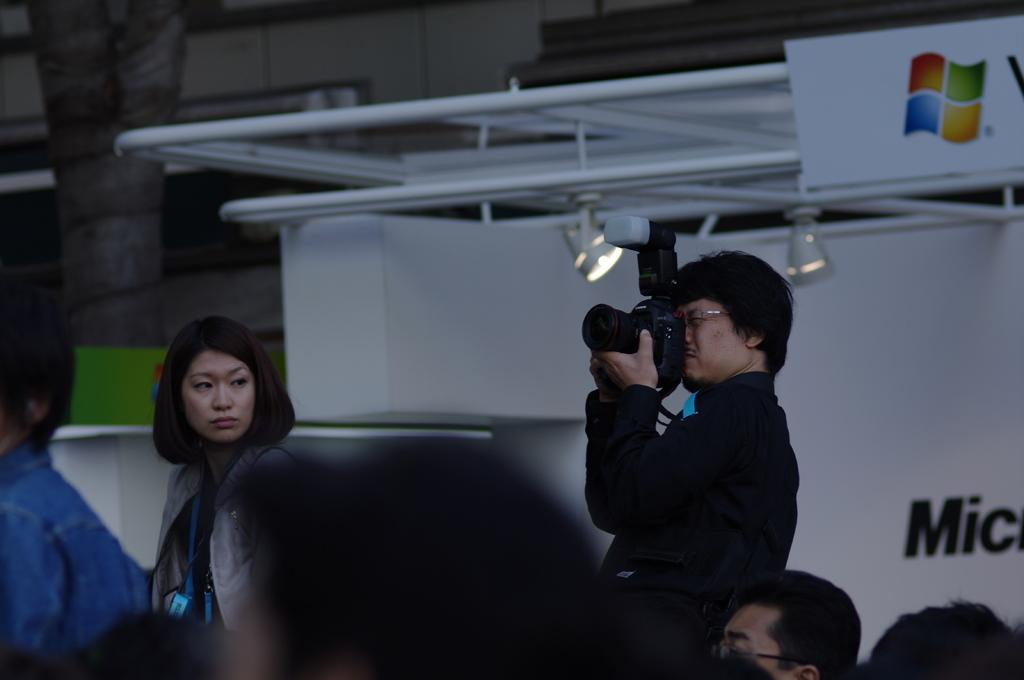How many people are in the image? There are people in the image, but the exact number is not specified. What is one person doing in the image? One person is standing and holding a camera. What can be seen on the wall in the image? There is a poster in the image. What is the logo of in the image? There is a logo of a window in the image. What can be seen providing illumination in the image? There are lights visible in the image. Reasoning: Let's think step by following the guidelines to produce the conversation. We start by acknowledging the presence of people in the image, but we don't specify the exact number since it's not mentioned in the facts. Then, we describe the action of one person holding a camera. Next, we mention the poster on the wall. After that, we identify the logo of a window in the image. Finally, we describe the lights providing illumination. Absurd Question/Answer: What type of wall is the person's aunt leaning against in the image? There is no mention of a wall or an aunt in the image, so this question cannot be answered. 